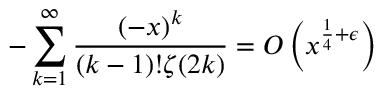<formula> <loc_0><loc_0><loc_500><loc_500>- \sum _ { k = 1 } ^ { \infty } { \frac { ( - x ) ^ { k } } { ( k - 1 ) ! \zeta ( 2 k ) } } = O \left ( x ^ { { \frac { 1 } { 4 } } + \epsilon } \right )</formula> 